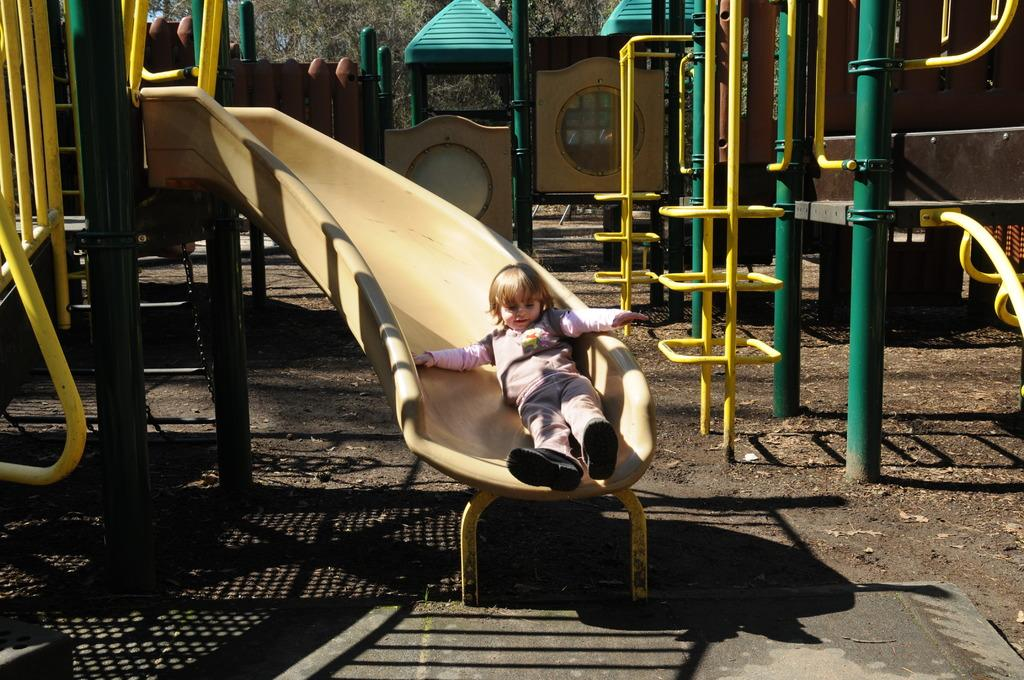Where was the image taken? The image was taken in a playground. What can be found in the playground? There are multiple slides in the playground. Can you describe the activity of one of the children in the image? There is a little girl on one of the slides. What type of sheet is being used by the children in the image? There is no sheet present in the image. The image features a playground with multiple slides, and a little girl on one of the slides. 